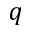<formula> <loc_0><loc_0><loc_500><loc_500>q</formula> 